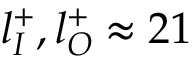Convert formula to latex. <formula><loc_0><loc_0><loc_500><loc_500>l _ { I } ^ { + } , l _ { O } ^ { + } \approx 2 1</formula> 